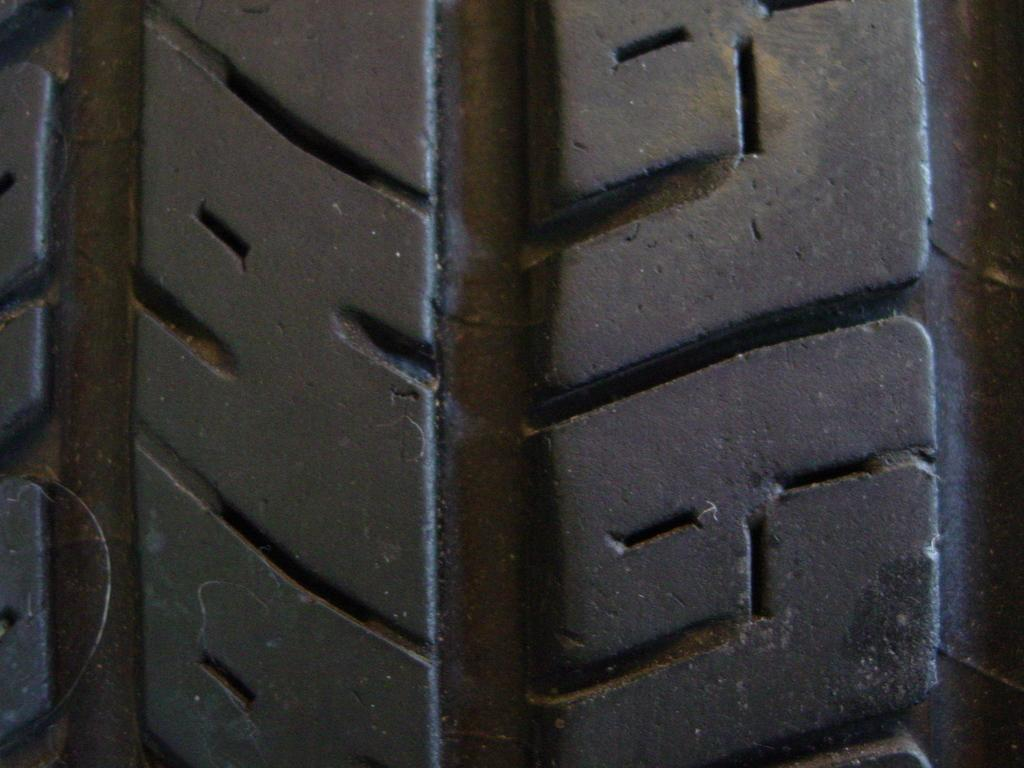What object can be seen in the image? There is a tire in the image. How many trains are visible in the image? There are no trains present in the image; it only features a tire. What time of day is depicted in the image? The time of day cannot be determined from the image, as it only shows a tire. 